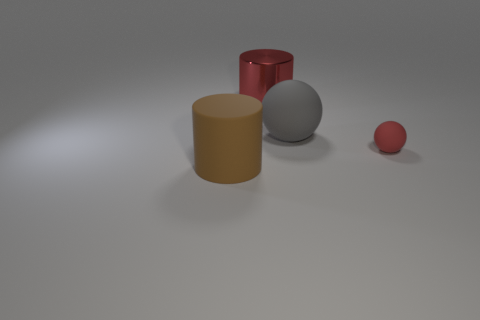Add 2 big red things. How many objects exist? 6 Add 4 small red matte objects. How many small red matte objects are left? 5 Add 3 big gray spheres. How many big gray spheres exist? 4 Subtract 0 purple cylinders. How many objects are left? 4 Subtract all cylinders. Subtract all rubber cylinders. How many objects are left? 1 